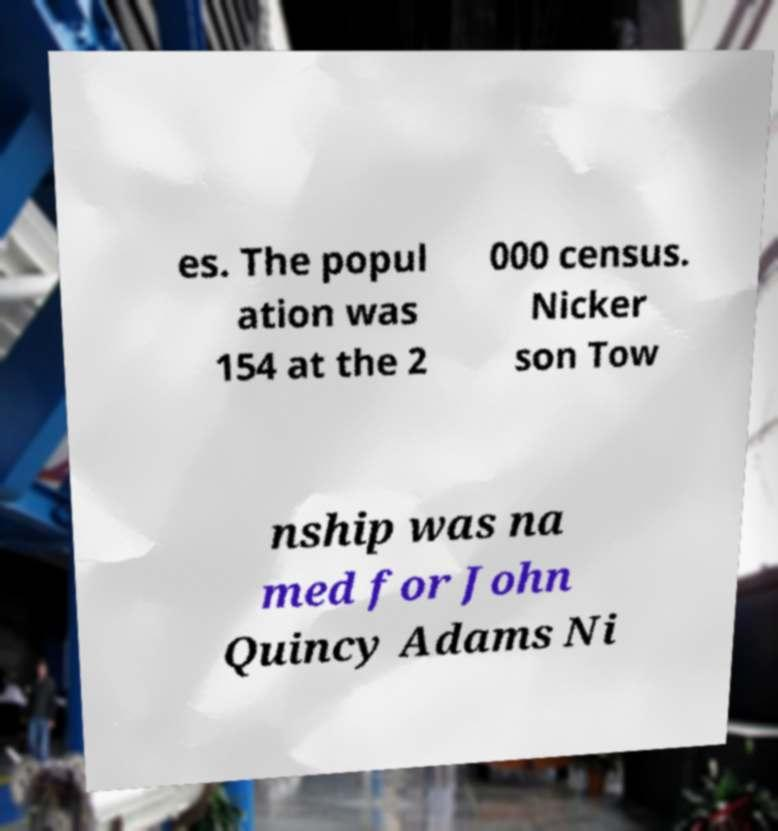Could you extract and type out the text from this image? es. The popul ation was 154 at the 2 000 census. Nicker son Tow nship was na med for John Quincy Adams Ni 